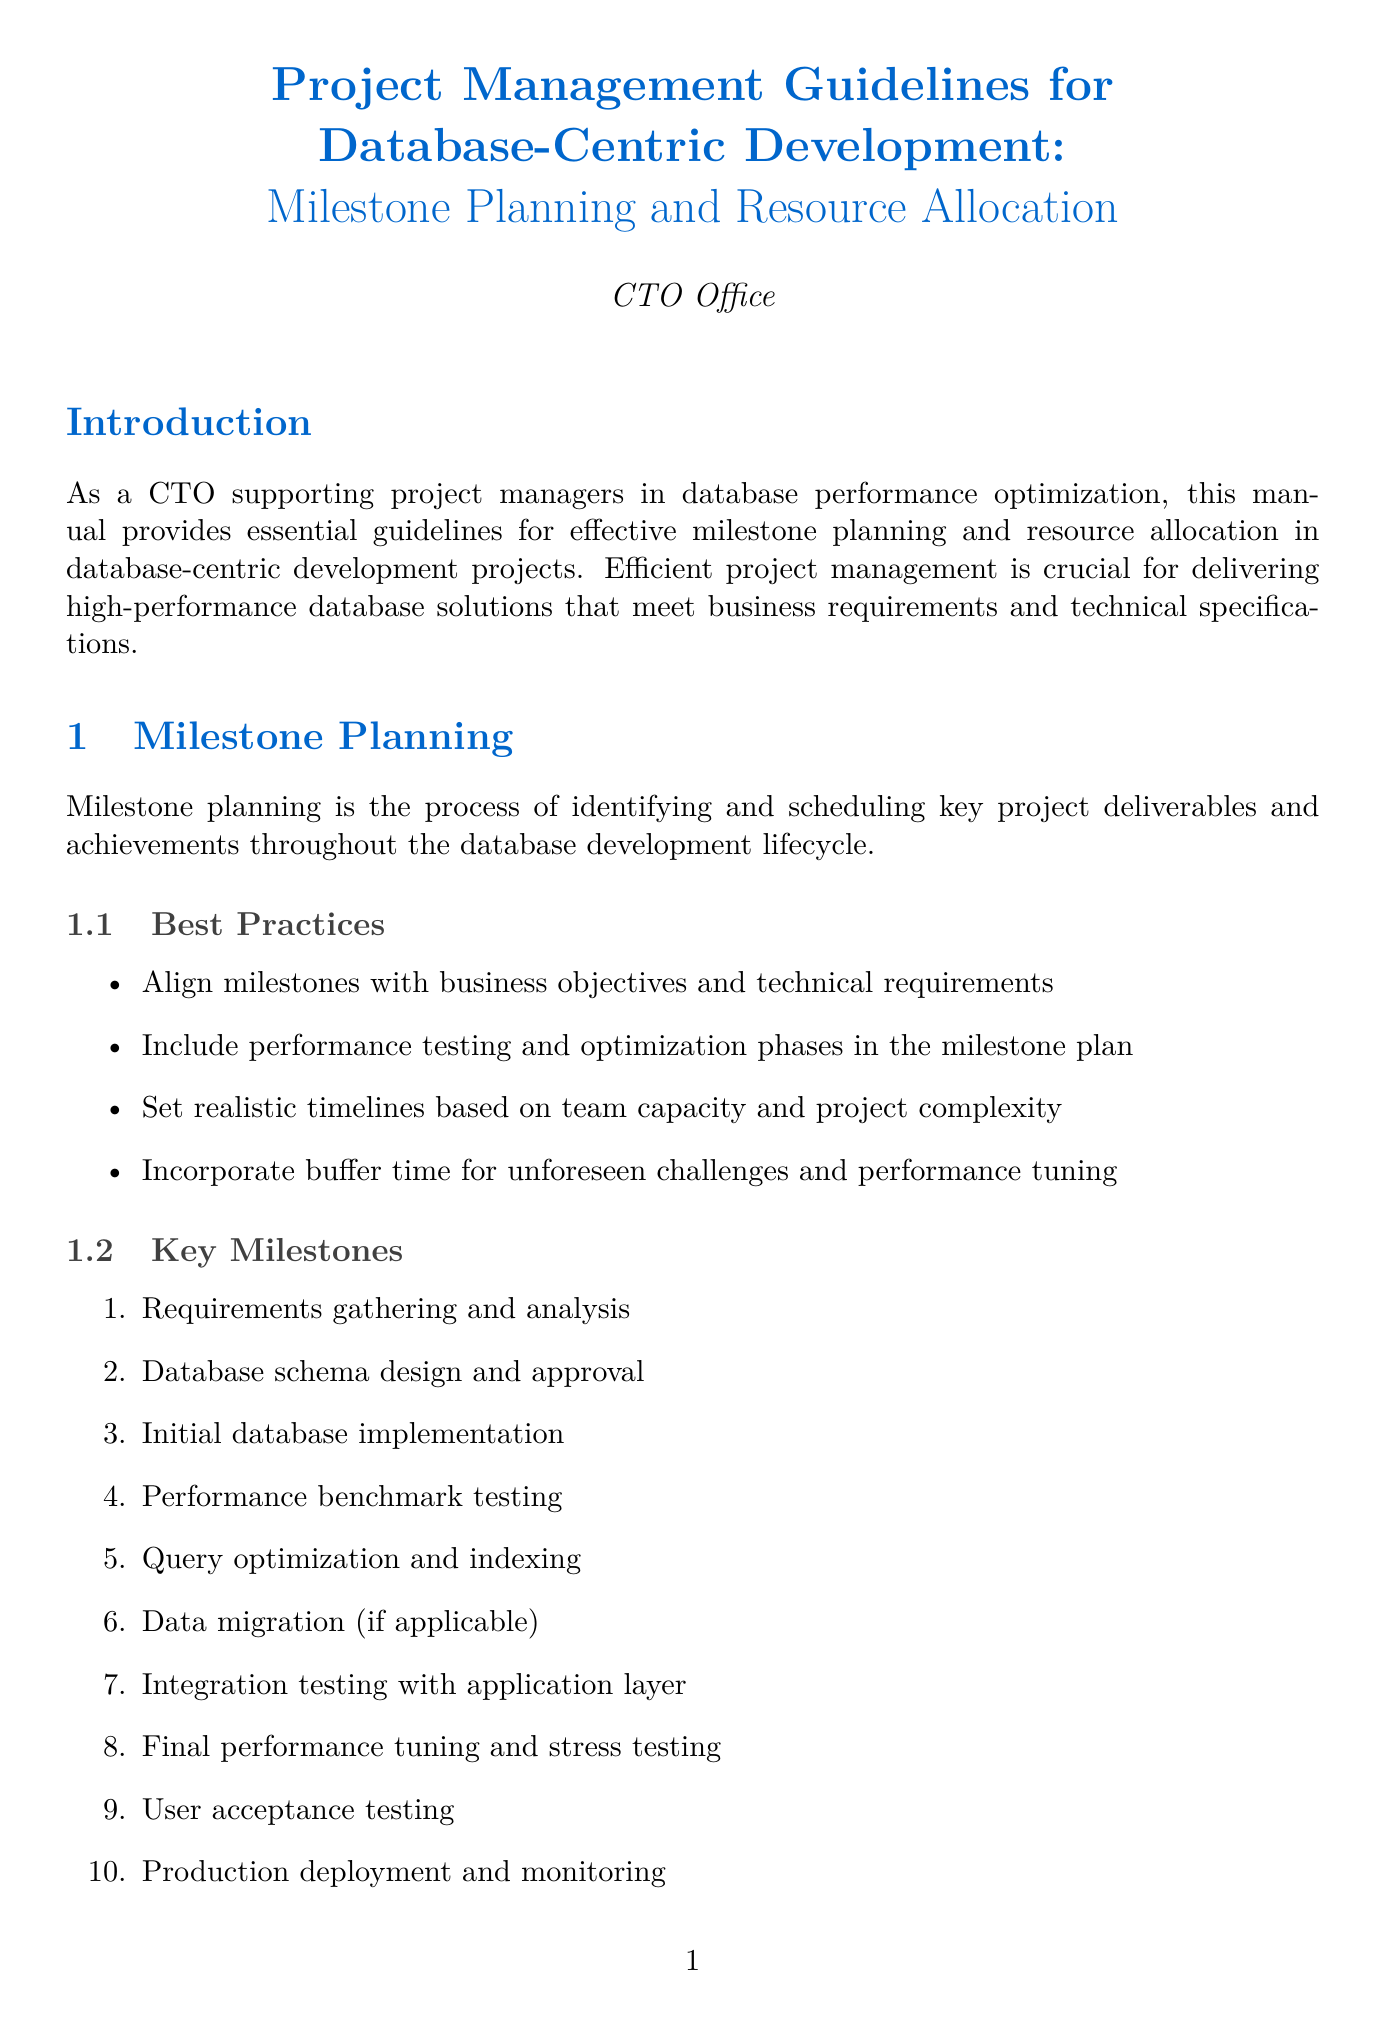What is the primary focus of this manual? The manual provides essential guidelines for effective milestone planning and resource allocation in database-centric development projects.
Answer: milestone planning and resource allocation What is the first key milestone listed? The first key milestone is that it denotes the initial project deliverable in the development lifecycle.
Answer: Requirements gathering and analysis Which project management tool is recommended for Agile project management? This tool is specifically noted for its use case in Agile environments within the document.
Answer: Jira What is one of the key considerations for resource allocation? This refers to the essential aspects that need to be addressed when allocating resources in the project.
Answer: Skill set requirements for database administrators, developers, and performance specialists Name one common risk identified in the document. This specifies potential risks that can impede project success based on project documentation.
Answer: Inadequate hardware resources leading to performance issues What is the total number of key performance areas listed? This counts all specified strategies focused on improving database performance.
Answer: Six What does the conclusion emphasize as essential for project success? This underlines the crucial aspects that need to be prioritized throughout the project lifecycle.
Answer: database performance What type of resources does the "Technical Resources" section mention? This specifies the category of resources and examples that are necessary for completing the project.
Answer: Development servers (e.g., Dell PowerEdge R740) What should be included in the milestone plan according to best practices? This outlines a critical activity that should be integrated within the timeline for effective project management.
Answer: performance testing and optimization phases 